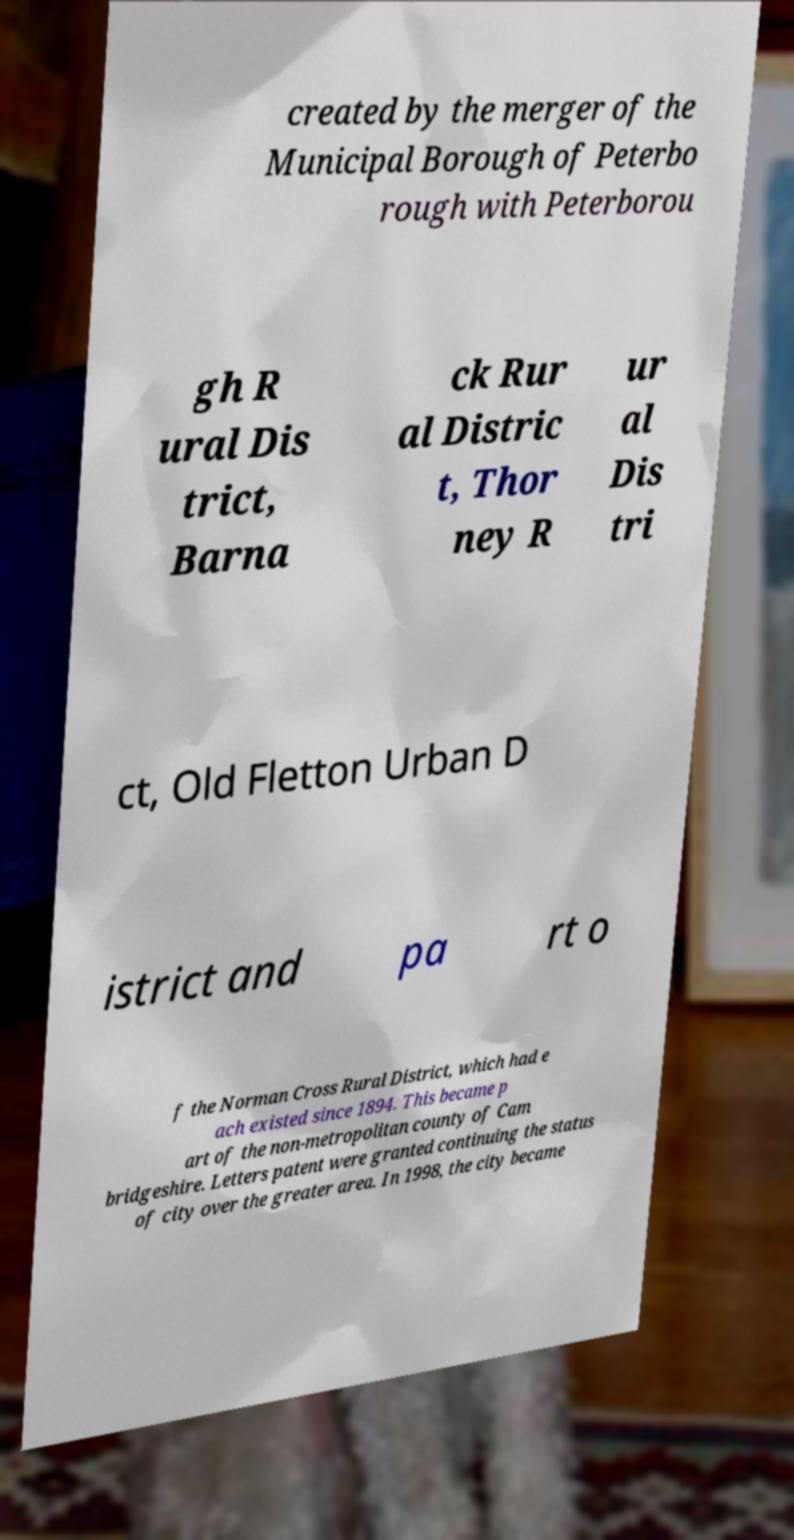Can you accurately transcribe the text from the provided image for me? created by the merger of the Municipal Borough of Peterbo rough with Peterborou gh R ural Dis trict, Barna ck Rur al Distric t, Thor ney R ur al Dis tri ct, Old Fletton Urban D istrict and pa rt o f the Norman Cross Rural District, which had e ach existed since 1894. This became p art of the non-metropolitan county of Cam bridgeshire. Letters patent were granted continuing the status of city over the greater area. In 1998, the city became 